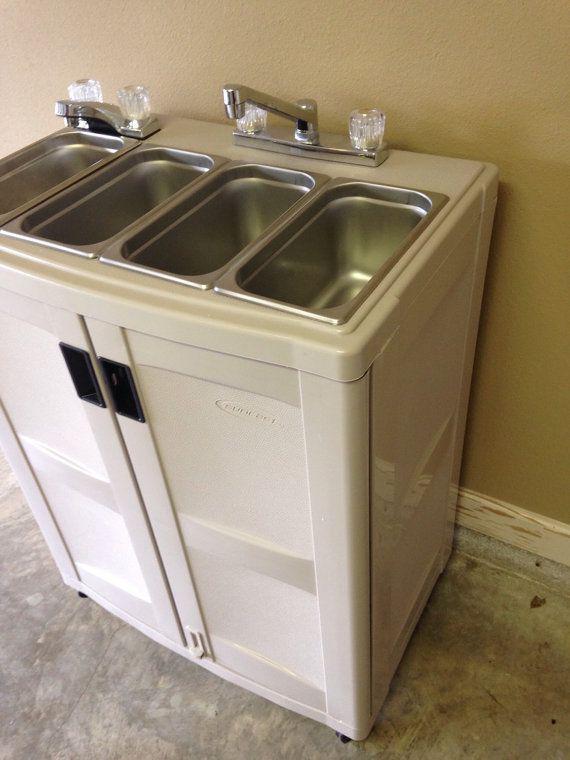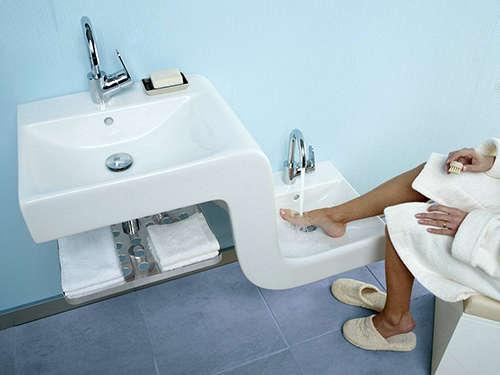The first image is the image on the left, the second image is the image on the right. Examine the images to the left and right. Is the description "A sink unit has a rectangular double-door cabinet underneath at least one rectangular inset sink." accurate? Answer yes or no. Yes. 